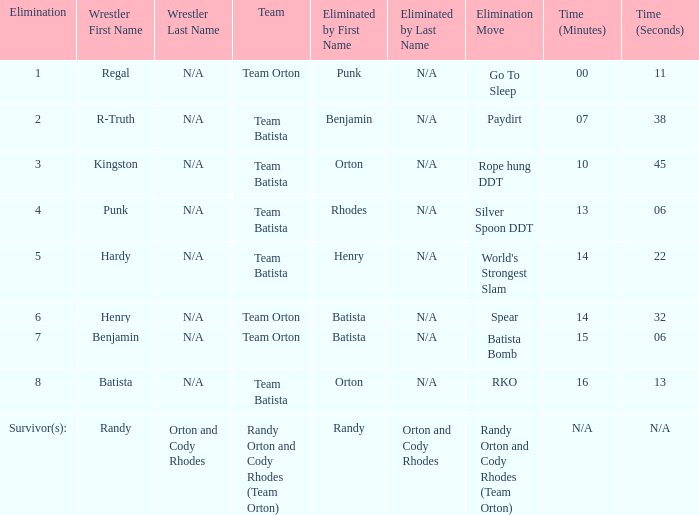What time was the Wrestler Henry eliminated by Batista? 14:32. 